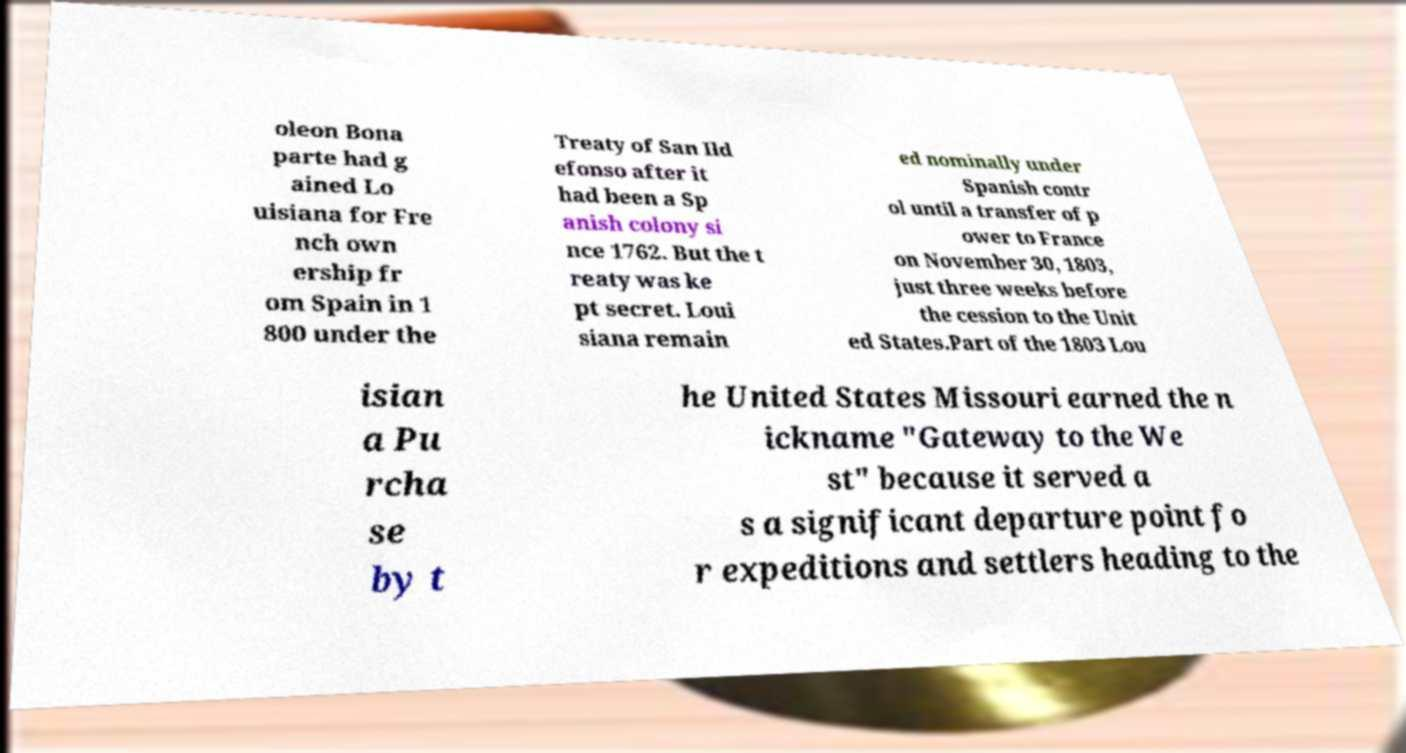Could you assist in decoding the text presented in this image and type it out clearly? oleon Bona parte had g ained Lo uisiana for Fre nch own ership fr om Spain in 1 800 under the Treaty of San Ild efonso after it had been a Sp anish colony si nce 1762. But the t reaty was ke pt secret. Loui siana remain ed nominally under Spanish contr ol until a transfer of p ower to France on November 30, 1803, just three weeks before the cession to the Unit ed States.Part of the 1803 Lou isian a Pu rcha se by t he United States Missouri earned the n ickname "Gateway to the We st" because it served a s a significant departure point fo r expeditions and settlers heading to the 